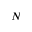<formula> <loc_0><loc_0><loc_500><loc_500>N</formula> 